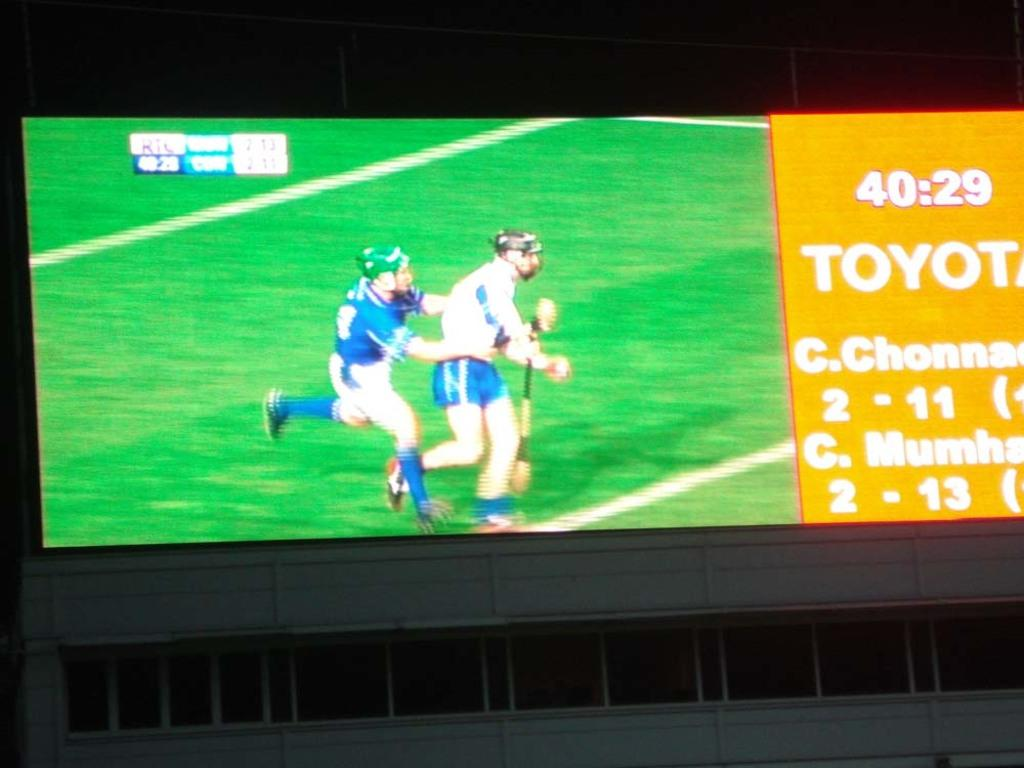<image>
Share a concise interpretation of the image provided. a jumbo screen showing two athletes running down a field with the toyota logo displayed on the right. 